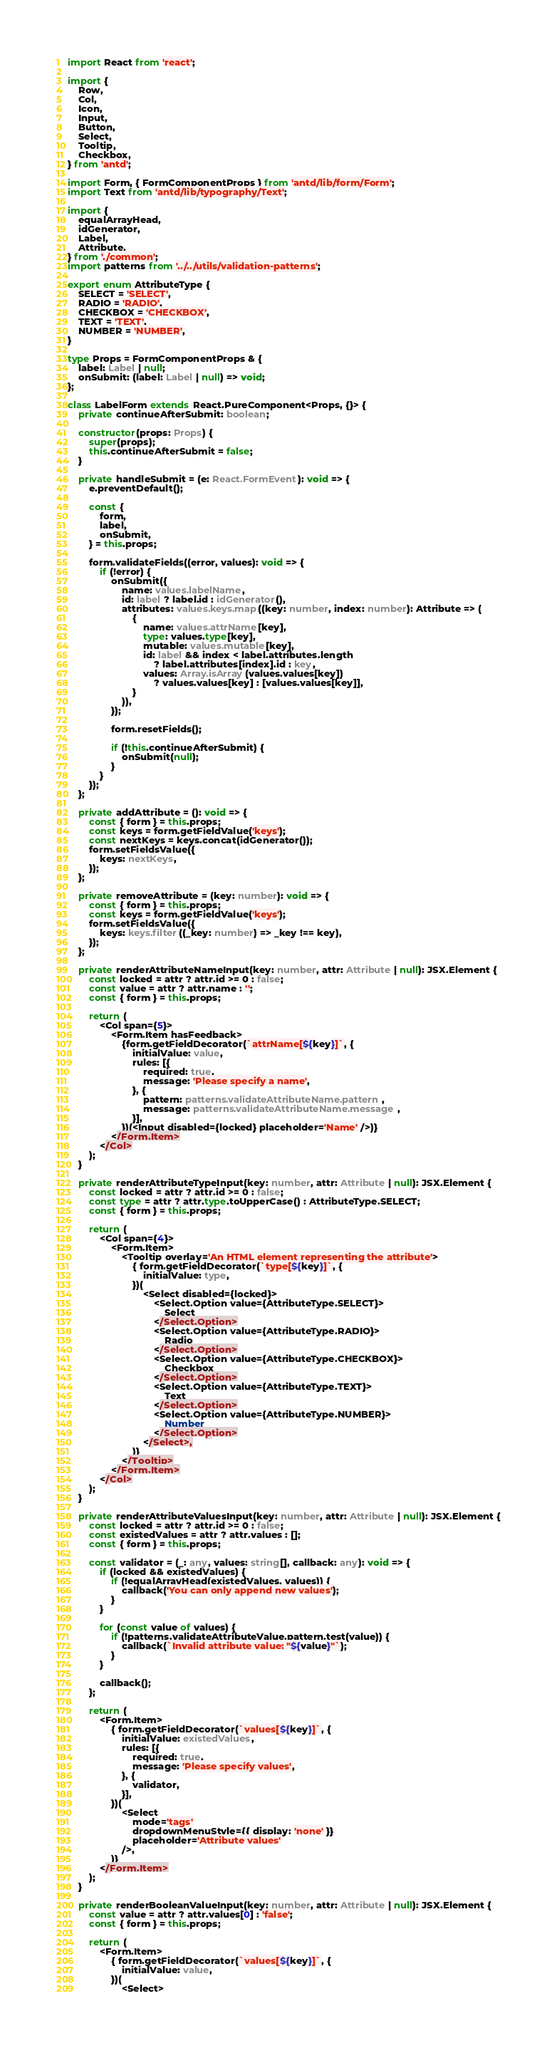<code> <loc_0><loc_0><loc_500><loc_500><_TypeScript_>import React from 'react';

import {
    Row,
    Col,
    Icon,
    Input,
    Button,
    Select,
    Tooltip,
    Checkbox,
} from 'antd';

import Form, { FormComponentProps } from 'antd/lib/form/Form';
import Text from 'antd/lib/typography/Text';

import {
    equalArrayHead,
    idGenerator,
    Label,
    Attribute,
} from './common';
import patterns from '../../utils/validation-patterns';

export enum AttributeType {
    SELECT = 'SELECT',
    RADIO = 'RADIO',
    CHECKBOX = 'CHECKBOX',
    TEXT = 'TEXT',
    NUMBER = 'NUMBER',
}

type Props = FormComponentProps & {
    label: Label | null;
    onSubmit: (label: Label | null) => void;
};

class LabelForm extends React.PureComponent<Props, {}> {
    private continueAfterSubmit: boolean;

    constructor(props: Props) {
        super(props);
        this.continueAfterSubmit = false;
    }

    private handleSubmit = (e: React.FormEvent): void => {
        e.preventDefault();

        const {
            form,
            label,
            onSubmit,
        } = this.props;

        form.validateFields((error, values): void => {
            if (!error) {
                onSubmit({
                    name: values.labelName,
                    id: label ? label.id : idGenerator(),
                    attributes: values.keys.map((key: number, index: number): Attribute => (
                        {
                            name: values.attrName[key],
                            type: values.type[key],
                            mutable: values.mutable[key],
                            id: label && index < label.attributes.length
                                ? label.attributes[index].id : key,
                            values: Array.isArray(values.values[key])
                                ? values.values[key] : [values.values[key]],
                        }
                    )),
                });

                form.resetFields();

                if (!this.continueAfterSubmit) {
                    onSubmit(null);
                }
            }
        });
    };

    private addAttribute = (): void => {
        const { form } = this.props;
        const keys = form.getFieldValue('keys');
        const nextKeys = keys.concat(idGenerator());
        form.setFieldsValue({
            keys: nextKeys,
        });
    };

    private removeAttribute = (key: number): void => {
        const { form } = this.props;
        const keys = form.getFieldValue('keys');
        form.setFieldsValue({
            keys: keys.filter((_key: number) => _key !== key),
        });
    };

    private renderAttributeNameInput(key: number, attr: Attribute | null): JSX.Element {
        const locked = attr ? attr.id >= 0 : false;
        const value = attr ? attr.name : '';
        const { form } = this.props;

        return (
            <Col span={5}>
                <Form.Item hasFeedback>
                    {form.getFieldDecorator(`attrName[${key}]`, {
                        initialValue: value,
                        rules: [{
                            required: true,
                            message: 'Please specify a name',
                        }, {
                            pattern: patterns.validateAttributeName.pattern,
                            message: patterns.validateAttributeName.message,
                        }],
                    })(<Input disabled={locked} placeholder='Name' />)}
                </Form.Item>
            </Col>
        );
    }

    private renderAttributeTypeInput(key: number, attr: Attribute | null): JSX.Element {
        const locked = attr ? attr.id >= 0 : false;
        const type = attr ? attr.type.toUpperCase() : AttributeType.SELECT;
        const { form } = this.props;

        return (
            <Col span={4}>
                <Form.Item>
                    <Tooltip overlay='An HTML element representing the attribute'>
                        { form.getFieldDecorator(`type[${key}]`, {
                            initialValue: type,
                        })(
                            <Select disabled={locked}>
                                <Select.Option value={AttributeType.SELECT}>
                                    Select
                                </Select.Option>
                                <Select.Option value={AttributeType.RADIO}>
                                    Radio
                                </Select.Option>
                                <Select.Option value={AttributeType.CHECKBOX}>
                                    Checkbox
                                </Select.Option>
                                <Select.Option value={AttributeType.TEXT}>
                                    Text
                                </Select.Option>
                                <Select.Option value={AttributeType.NUMBER}>
                                    Number
                                </Select.Option>
                            </Select>,
                        )}
                    </Tooltip>
                </Form.Item>
            </Col>
        );
    }

    private renderAttributeValuesInput(key: number, attr: Attribute | null): JSX.Element {
        const locked = attr ? attr.id >= 0 : false;
        const existedValues = attr ? attr.values : [];
        const { form } = this.props;

        const validator = (_: any, values: string[], callback: any): void => {
            if (locked && existedValues) {
                if (!equalArrayHead(existedValues, values)) {
                    callback('You can only append new values');
                }
            }

            for (const value of values) {
                if (!patterns.validateAttributeValue.pattern.test(value)) {
                    callback(`Invalid attribute value: "${value}"`);
                }
            }

            callback();
        };

        return (
            <Form.Item>
                { form.getFieldDecorator(`values[${key}]`, {
                    initialValue: existedValues,
                    rules: [{
                        required: true,
                        message: 'Please specify values',
                    }, {
                        validator,
                    }],
                })(
                    <Select
                        mode='tags'
                        dropdownMenuStyle={{ display: 'none' }}
                        placeholder='Attribute values'
                    />,
                )}
            </Form.Item>
        );
    }

    private renderBooleanValueInput(key: number, attr: Attribute | null): JSX.Element {
        const value = attr ? attr.values[0] : 'false';
        const { form } = this.props;

        return (
            <Form.Item>
                { form.getFieldDecorator(`values[${key}]`, {
                    initialValue: value,
                })(
                    <Select></code> 